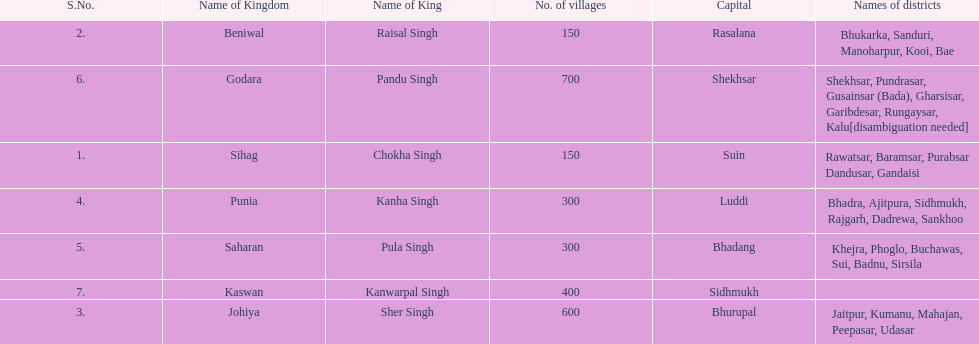Could you parse the entire table as a dict? {'header': ['S.No.', 'Name of Kingdom', 'Name of King', 'No. of villages', 'Capital', 'Names of districts'], 'rows': [['2.', 'Beniwal', 'Raisal Singh', '150', 'Rasalana', 'Bhukarka, Sanduri, Manoharpur, Kooi, Bae'], ['6.', 'Godara', 'Pandu Singh', '700', 'Shekhsar', 'Shekhsar, Pundrasar, Gusainsar (Bada), Gharsisar, Garibdesar, Rungaysar, Kalu[disambiguation needed]'], ['1.', 'Sihag', 'Chokha Singh', '150', 'Suin', 'Rawatsar, Baramsar, Purabsar Dandusar, Gandaisi'], ['4.', 'Punia', 'Kanha Singh', '300', 'Luddi', 'Bhadra, Ajitpura, Sidhmukh, Rajgarh, Dadrewa, Sankhoo'], ['5.', 'Saharan', 'Pula Singh', '300', 'Bhadang', 'Khejra, Phoglo, Buchawas, Sui, Badnu, Sirsila'], ['7.', 'Kaswan', 'Kanwarpal Singh', '400', 'Sidhmukh', ''], ['3.', 'Johiya', 'Sher Singh', '600', 'Bhurupal', 'Jaitpur, Kumanu, Mahajan, Peepasar, Udasar']]} Does punia have more or less villages than godara? Less. 